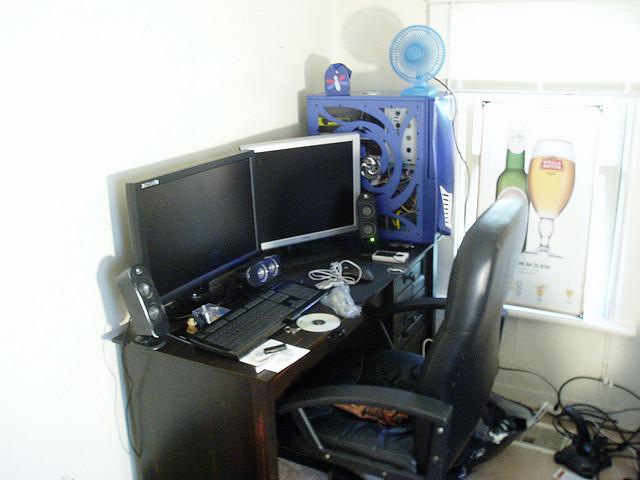Is the beer real?
Keep it brief. No. What is on the desk?
Be succinct. Computer. Is it indoors?
Write a very short answer. Yes. 